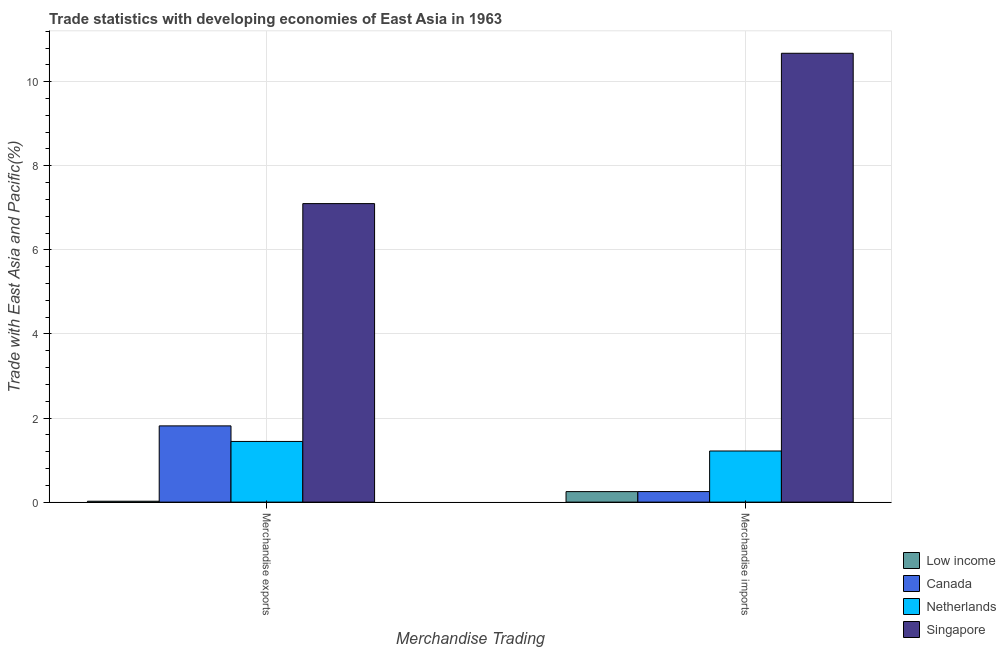Are the number of bars per tick equal to the number of legend labels?
Offer a very short reply. Yes. How many bars are there on the 1st tick from the right?
Offer a terse response. 4. What is the label of the 2nd group of bars from the left?
Give a very brief answer. Merchandise imports. What is the merchandise imports in Canada?
Provide a short and direct response. 0.25. Across all countries, what is the maximum merchandise imports?
Make the answer very short. 10.68. Across all countries, what is the minimum merchandise imports?
Ensure brevity in your answer.  0.25. In which country was the merchandise imports maximum?
Offer a terse response. Singapore. What is the total merchandise imports in the graph?
Your answer should be compact. 12.39. What is the difference between the merchandise exports in Low income and that in Canada?
Keep it short and to the point. -1.79. What is the difference between the merchandise imports in Low income and the merchandise exports in Singapore?
Provide a short and direct response. -6.85. What is the average merchandise imports per country?
Your response must be concise. 3.1. What is the difference between the merchandise imports and merchandise exports in Singapore?
Give a very brief answer. 3.58. What is the ratio of the merchandise imports in Low income to that in Canada?
Provide a succinct answer. 1. How many countries are there in the graph?
Keep it short and to the point. 4. What is the difference between two consecutive major ticks on the Y-axis?
Offer a very short reply. 2. Does the graph contain grids?
Give a very brief answer. Yes. Where does the legend appear in the graph?
Make the answer very short. Bottom right. How many legend labels are there?
Give a very brief answer. 4. What is the title of the graph?
Ensure brevity in your answer.  Trade statistics with developing economies of East Asia in 1963. What is the label or title of the X-axis?
Ensure brevity in your answer.  Merchandise Trading. What is the label or title of the Y-axis?
Keep it short and to the point. Trade with East Asia and Pacific(%). What is the Trade with East Asia and Pacific(%) of Low income in Merchandise exports?
Provide a short and direct response. 0.02. What is the Trade with East Asia and Pacific(%) in Canada in Merchandise exports?
Your answer should be very brief. 1.81. What is the Trade with East Asia and Pacific(%) of Netherlands in Merchandise exports?
Keep it short and to the point. 1.44. What is the Trade with East Asia and Pacific(%) of Singapore in Merchandise exports?
Offer a very short reply. 7.1. What is the Trade with East Asia and Pacific(%) of Low income in Merchandise imports?
Your answer should be compact. 0.25. What is the Trade with East Asia and Pacific(%) of Canada in Merchandise imports?
Your response must be concise. 0.25. What is the Trade with East Asia and Pacific(%) of Netherlands in Merchandise imports?
Provide a succinct answer. 1.22. What is the Trade with East Asia and Pacific(%) of Singapore in Merchandise imports?
Offer a very short reply. 10.68. Across all Merchandise Trading, what is the maximum Trade with East Asia and Pacific(%) in Low income?
Make the answer very short. 0.25. Across all Merchandise Trading, what is the maximum Trade with East Asia and Pacific(%) of Canada?
Ensure brevity in your answer.  1.81. Across all Merchandise Trading, what is the maximum Trade with East Asia and Pacific(%) in Netherlands?
Your answer should be compact. 1.44. Across all Merchandise Trading, what is the maximum Trade with East Asia and Pacific(%) in Singapore?
Provide a short and direct response. 10.68. Across all Merchandise Trading, what is the minimum Trade with East Asia and Pacific(%) of Low income?
Provide a succinct answer. 0.02. Across all Merchandise Trading, what is the minimum Trade with East Asia and Pacific(%) of Canada?
Your answer should be very brief. 0.25. Across all Merchandise Trading, what is the minimum Trade with East Asia and Pacific(%) of Netherlands?
Your answer should be compact. 1.22. Across all Merchandise Trading, what is the minimum Trade with East Asia and Pacific(%) in Singapore?
Provide a succinct answer. 7.1. What is the total Trade with East Asia and Pacific(%) in Low income in the graph?
Your response must be concise. 0.27. What is the total Trade with East Asia and Pacific(%) of Canada in the graph?
Make the answer very short. 2.06. What is the total Trade with East Asia and Pacific(%) of Netherlands in the graph?
Offer a terse response. 2.66. What is the total Trade with East Asia and Pacific(%) of Singapore in the graph?
Give a very brief answer. 17.78. What is the difference between the Trade with East Asia and Pacific(%) of Low income in Merchandise exports and that in Merchandise imports?
Provide a succinct answer. -0.23. What is the difference between the Trade with East Asia and Pacific(%) of Canada in Merchandise exports and that in Merchandise imports?
Your answer should be compact. 1.56. What is the difference between the Trade with East Asia and Pacific(%) of Netherlands in Merchandise exports and that in Merchandise imports?
Offer a very short reply. 0.23. What is the difference between the Trade with East Asia and Pacific(%) of Singapore in Merchandise exports and that in Merchandise imports?
Provide a short and direct response. -3.58. What is the difference between the Trade with East Asia and Pacific(%) in Low income in Merchandise exports and the Trade with East Asia and Pacific(%) in Canada in Merchandise imports?
Your answer should be very brief. -0.23. What is the difference between the Trade with East Asia and Pacific(%) of Low income in Merchandise exports and the Trade with East Asia and Pacific(%) of Netherlands in Merchandise imports?
Ensure brevity in your answer.  -1.19. What is the difference between the Trade with East Asia and Pacific(%) in Low income in Merchandise exports and the Trade with East Asia and Pacific(%) in Singapore in Merchandise imports?
Make the answer very short. -10.65. What is the difference between the Trade with East Asia and Pacific(%) in Canada in Merchandise exports and the Trade with East Asia and Pacific(%) in Netherlands in Merchandise imports?
Your response must be concise. 0.6. What is the difference between the Trade with East Asia and Pacific(%) of Canada in Merchandise exports and the Trade with East Asia and Pacific(%) of Singapore in Merchandise imports?
Your answer should be very brief. -8.86. What is the difference between the Trade with East Asia and Pacific(%) of Netherlands in Merchandise exports and the Trade with East Asia and Pacific(%) of Singapore in Merchandise imports?
Make the answer very short. -9.23. What is the average Trade with East Asia and Pacific(%) of Low income per Merchandise Trading?
Make the answer very short. 0.14. What is the average Trade with East Asia and Pacific(%) of Canada per Merchandise Trading?
Make the answer very short. 1.03. What is the average Trade with East Asia and Pacific(%) in Netherlands per Merchandise Trading?
Provide a succinct answer. 1.33. What is the average Trade with East Asia and Pacific(%) in Singapore per Merchandise Trading?
Offer a terse response. 8.89. What is the difference between the Trade with East Asia and Pacific(%) of Low income and Trade with East Asia and Pacific(%) of Canada in Merchandise exports?
Your answer should be very brief. -1.79. What is the difference between the Trade with East Asia and Pacific(%) in Low income and Trade with East Asia and Pacific(%) in Netherlands in Merchandise exports?
Your response must be concise. -1.42. What is the difference between the Trade with East Asia and Pacific(%) of Low income and Trade with East Asia and Pacific(%) of Singapore in Merchandise exports?
Your response must be concise. -7.08. What is the difference between the Trade with East Asia and Pacific(%) of Canada and Trade with East Asia and Pacific(%) of Netherlands in Merchandise exports?
Offer a very short reply. 0.37. What is the difference between the Trade with East Asia and Pacific(%) in Canada and Trade with East Asia and Pacific(%) in Singapore in Merchandise exports?
Keep it short and to the point. -5.29. What is the difference between the Trade with East Asia and Pacific(%) of Netherlands and Trade with East Asia and Pacific(%) of Singapore in Merchandise exports?
Provide a short and direct response. -5.66. What is the difference between the Trade with East Asia and Pacific(%) in Low income and Trade with East Asia and Pacific(%) in Canada in Merchandise imports?
Your answer should be compact. -0. What is the difference between the Trade with East Asia and Pacific(%) of Low income and Trade with East Asia and Pacific(%) of Netherlands in Merchandise imports?
Your answer should be compact. -0.97. What is the difference between the Trade with East Asia and Pacific(%) in Low income and Trade with East Asia and Pacific(%) in Singapore in Merchandise imports?
Provide a succinct answer. -10.43. What is the difference between the Trade with East Asia and Pacific(%) in Canada and Trade with East Asia and Pacific(%) in Netherlands in Merchandise imports?
Offer a very short reply. -0.96. What is the difference between the Trade with East Asia and Pacific(%) in Canada and Trade with East Asia and Pacific(%) in Singapore in Merchandise imports?
Ensure brevity in your answer.  -10.42. What is the difference between the Trade with East Asia and Pacific(%) of Netherlands and Trade with East Asia and Pacific(%) of Singapore in Merchandise imports?
Ensure brevity in your answer.  -9.46. What is the ratio of the Trade with East Asia and Pacific(%) of Low income in Merchandise exports to that in Merchandise imports?
Make the answer very short. 0.09. What is the ratio of the Trade with East Asia and Pacific(%) in Canada in Merchandise exports to that in Merchandise imports?
Your response must be concise. 7.22. What is the ratio of the Trade with East Asia and Pacific(%) in Netherlands in Merchandise exports to that in Merchandise imports?
Make the answer very short. 1.19. What is the ratio of the Trade with East Asia and Pacific(%) in Singapore in Merchandise exports to that in Merchandise imports?
Make the answer very short. 0.67. What is the difference between the highest and the second highest Trade with East Asia and Pacific(%) in Low income?
Your answer should be very brief. 0.23. What is the difference between the highest and the second highest Trade with East Asia and Pacific(%) in Canada?
Provide a succinct answer. 1.56. What is the difference between the highest and the second highest Trade with East Asia and Pacific(%) in Netherlands?
Offer a very short reply. 0.23. What is the difference between the highest and the second highest Trade with East Asia and Pacific(%) in Singapore?
Your answer should be very brief. 3.58. What is the difference between the highest and the lowest Trade with East Asia and Pacific(%) of Low income?
Ensure brevity in your answer.  0.23. What is the difference between the highest and the lowest Trade with East Asia and Pacific(%) in Canada?
Provide a succinct answer. 1.56. What is the difference between the highest and the lowest Trade with East Asia and Pacific(%) of Netherlands?
Ensure brevity in your answer.  0.23. What is the difference between the highest and the lowest Trade with East Asia and Pacific(%) of Singapore?
Offer a terse response. 3.58. 